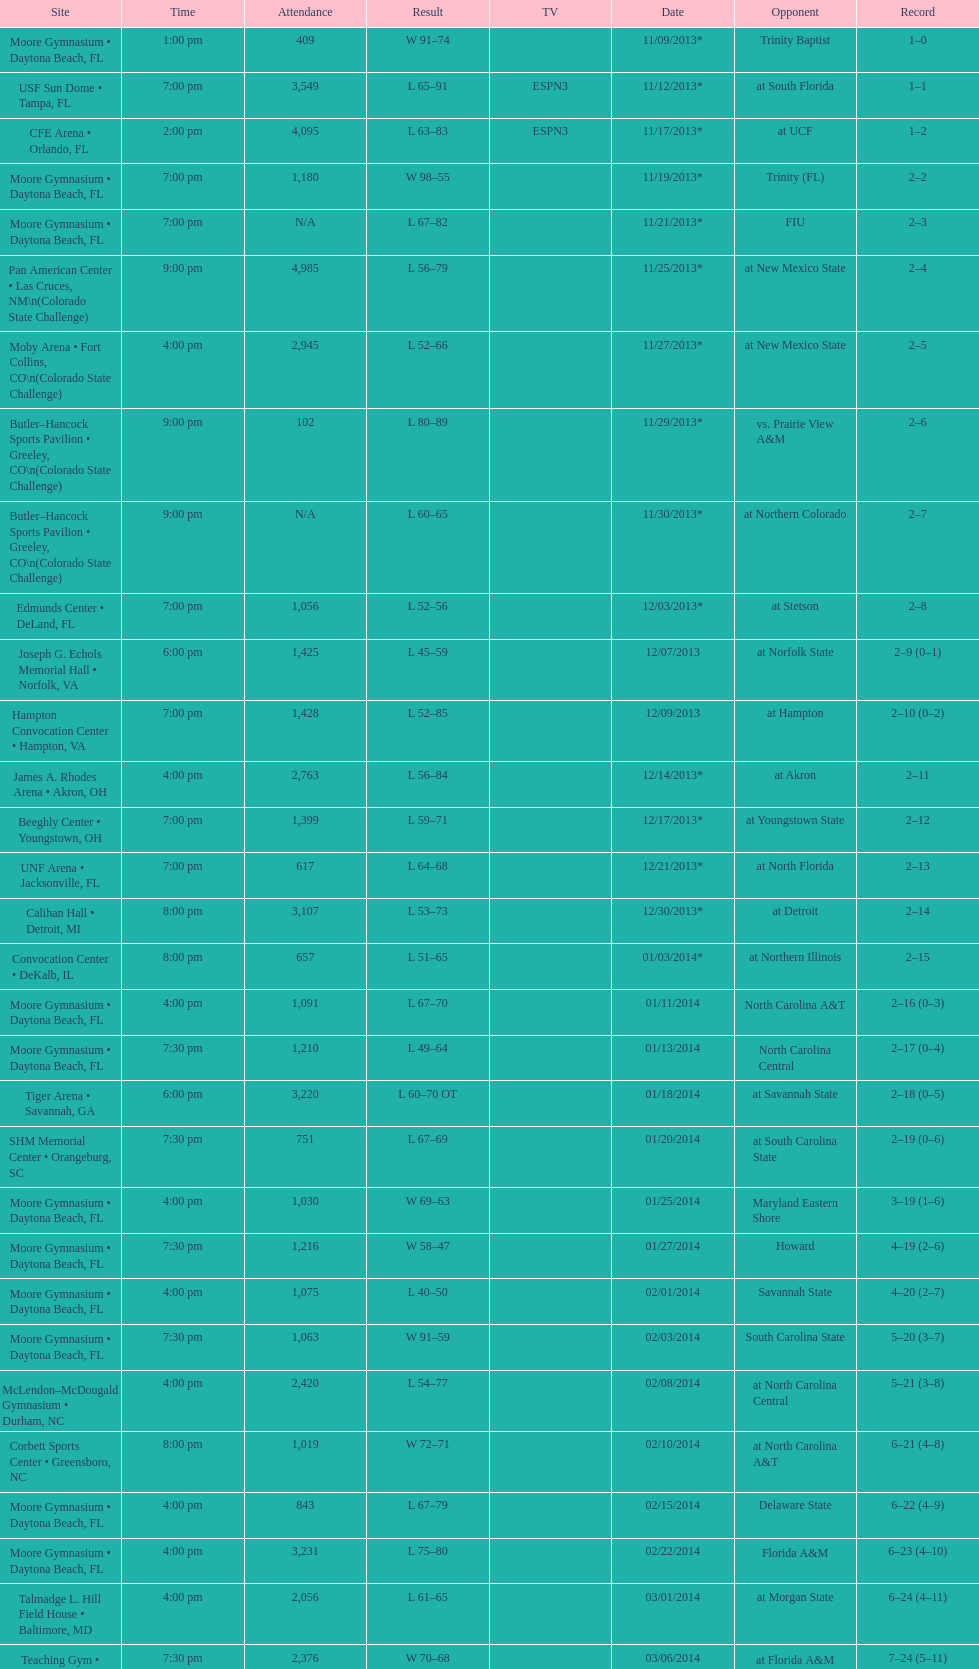How many games did the wildcats play in daytona beach, fl? 11. 